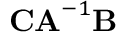<formula> <loc_0><loc_0><loc_500><loc_500>C A ^ { - 1 } B</formula> 